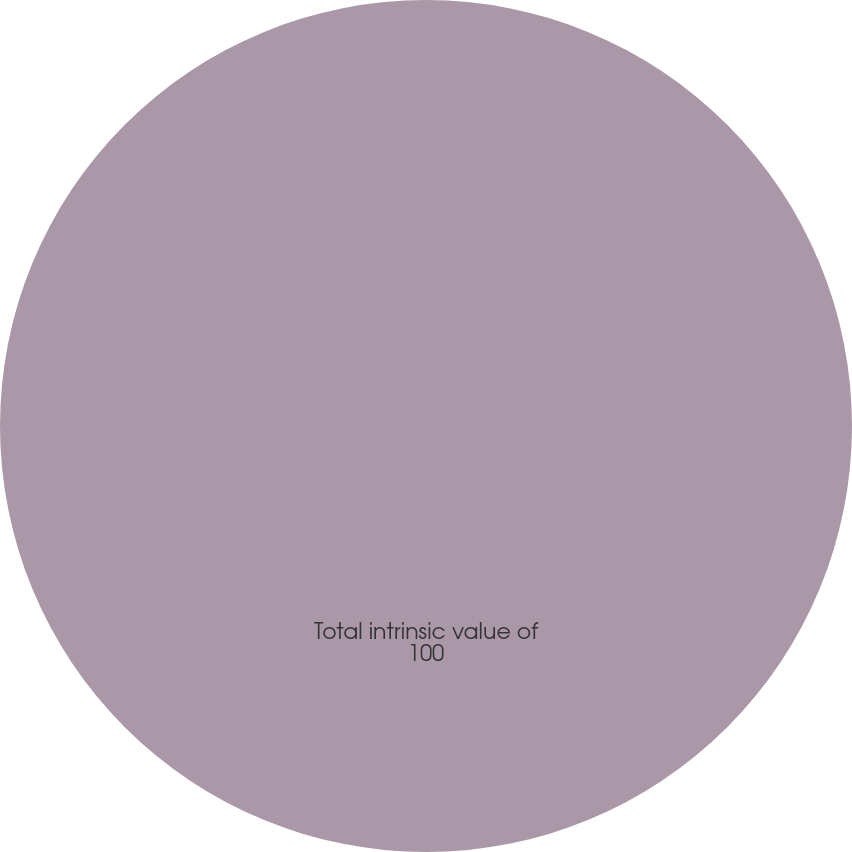Convert chart. <chart><loc_0><loc_0><loc_500><loc_500><pie_chart><fcel>Total intrinsic value of<nl><fcel>100.0%<nl></chart> 